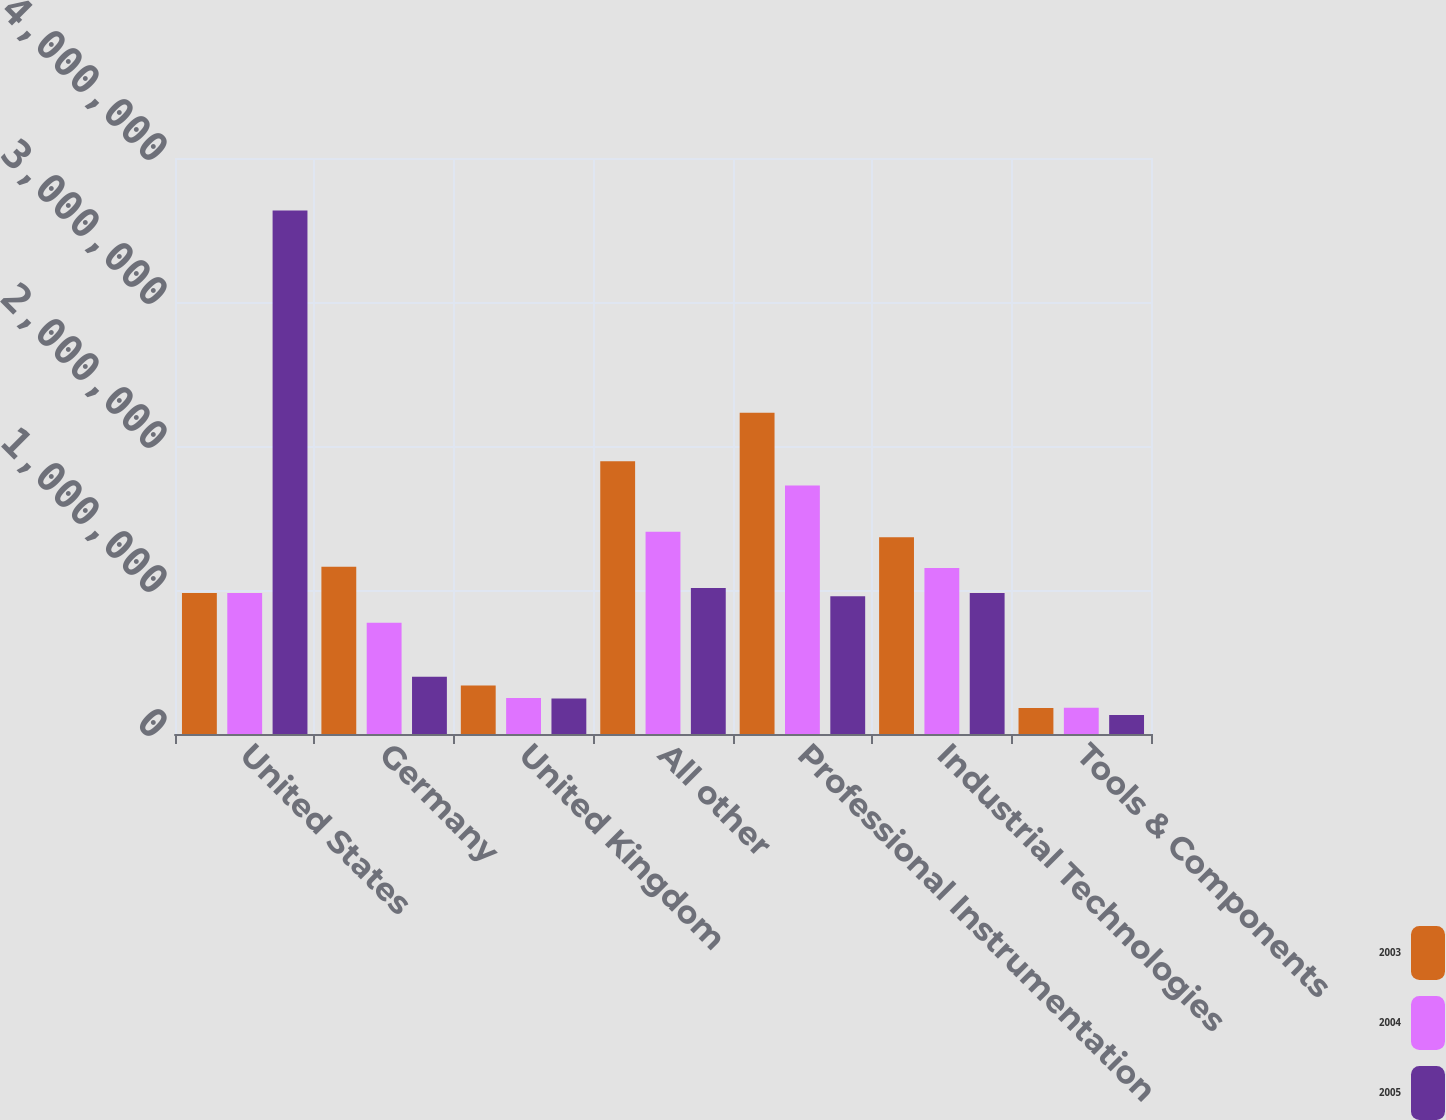Convert chart. <chart><loc_0><loc_0><loc_500><loc_500><stacked_bar_chart><ecel><fcel>United States<fcel>Germany<fcel>United Kingdom<fcel>All other<fcel>Professional Instrumentation<fcel>Industrial Technologies<fcel>Tools & Components<nl><fcel>2003<fcel>979291<fcel>1.16064e+06<fcel>336822<fcel>1.89426e+06<fcel>2.23144e+06<fcel>1.36683e+06<fcel>181224<nl><fcel>2004<fcel>979291<fcel>773163<fcel>250627<fcel>1.40412e+06<fcel>1.72597e+06<fcel>1.15363e+06<fcel>182876<nl><fcel>2005<fcel>3.6353e+06<fcel>398317<fcel>246959<fcel>1.0133e+06<fcel>956251<fcel>979291<fcel>131691<nl></chart> 